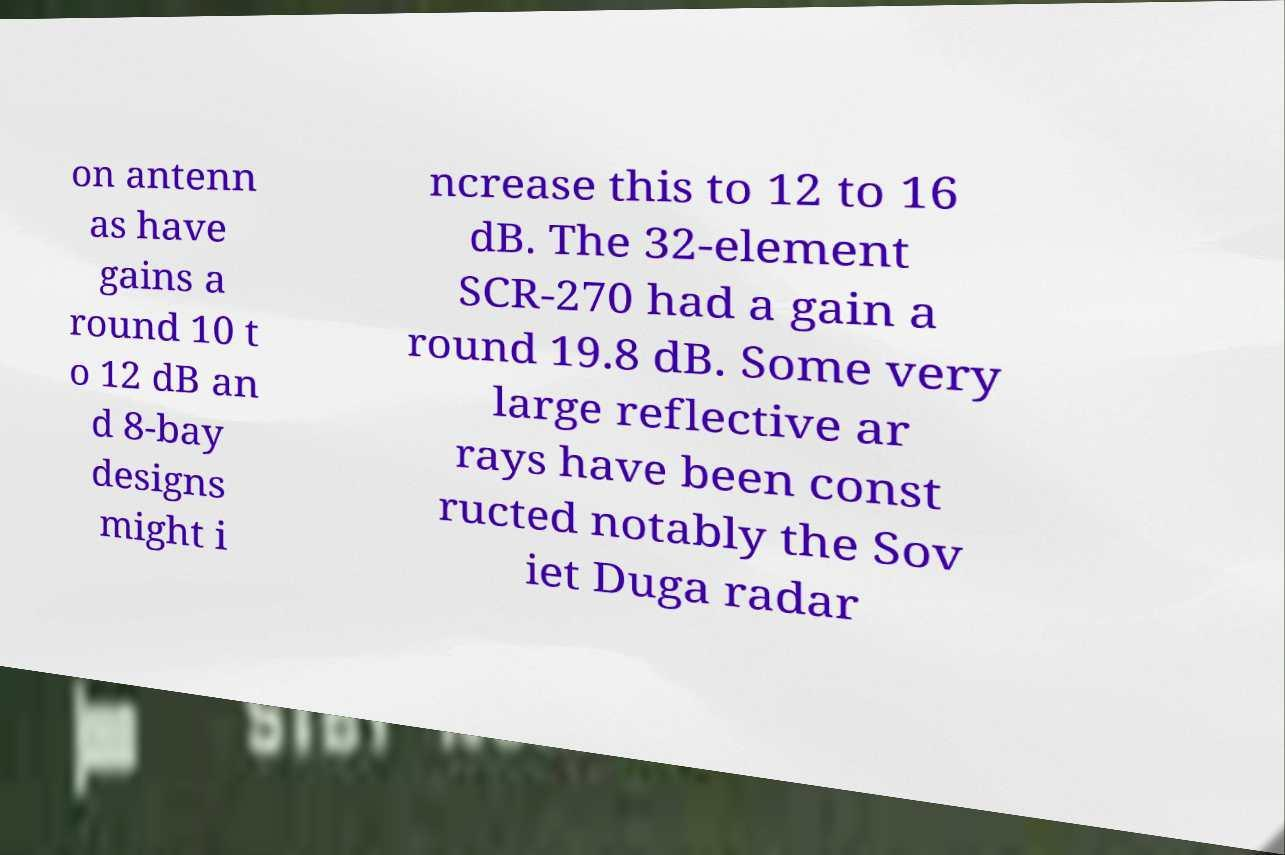Please identify and transcribe the text found in this image. on antenn as have gains a round 10 t o 12 dB an d 8-bay designs might i ncrease this to 12 to 16 dB. The 32-element SCR-270 had a gain a round 19.8 dB. Some very large reflective ar rays have been const ructed notably the Sov iet Duga radar 